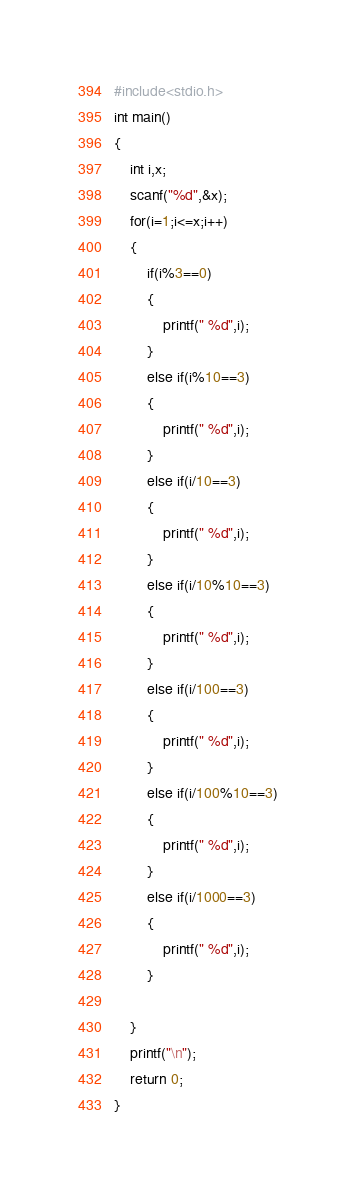<code> <loc_0><loc_0><loc_500><loc_500><_C_>#include<stdio.h>
int main()
{
    int i,x;
    scanf("%d",&x);
    for(i=1;i<=x;i++)
    {
        if(i%3==0)
        {
            printf(" %d",i);
        }
        else if(i%10==3)
        {
            printf(" %d",i);
        }
        else if(i/10==3)
        {
            printf(" %d",i);
        }
        else if(i/10%10==3)
        {
            printf(" %d",i);
        }
        else if(i/100==3)
        {
            printf(" %d",i);
        }
        else if(i/100%10==3)
        {
            printf(" %d",i);
        }
        else if(i/1000==3)
        {
            printf(" %d",i);
        }

    }
    printf("\n");
    return 0;
}</code> 